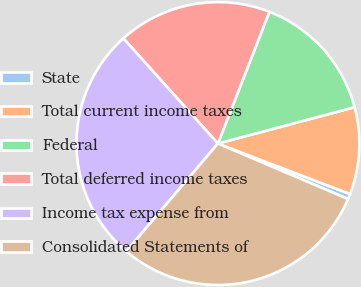Convert chart to OTSL. <chart><loc_0><loc_0><loc_500><loc_500><pie_chart><fcel>State<fcel>Total current income taxes<fcel>Federal<fcel>Total deferred income taxes<fcel>Income tax expense from<fcel>Consolidated Statements of<nl><fcel>0.61%<fcel>9.95%<fcel>14.93%<fcel>17.58%<fcel>27.14%<fcel>29.79%<nl></chart> 